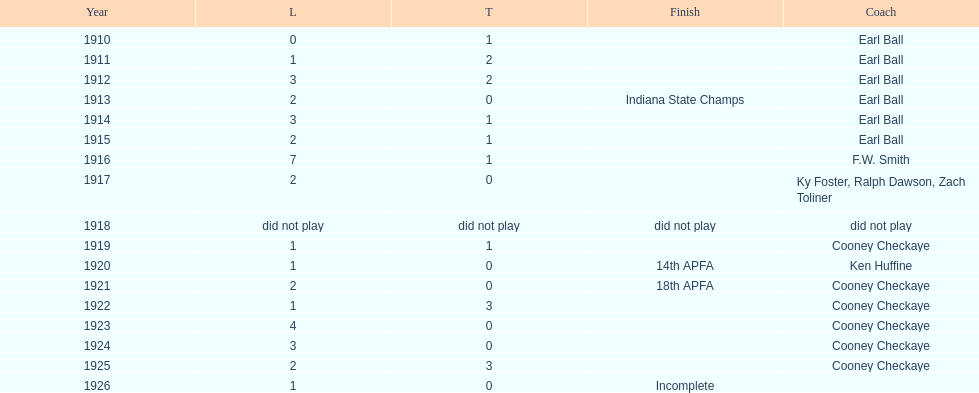How many years did cooney checkaye coach the muncie flyers? 6. 